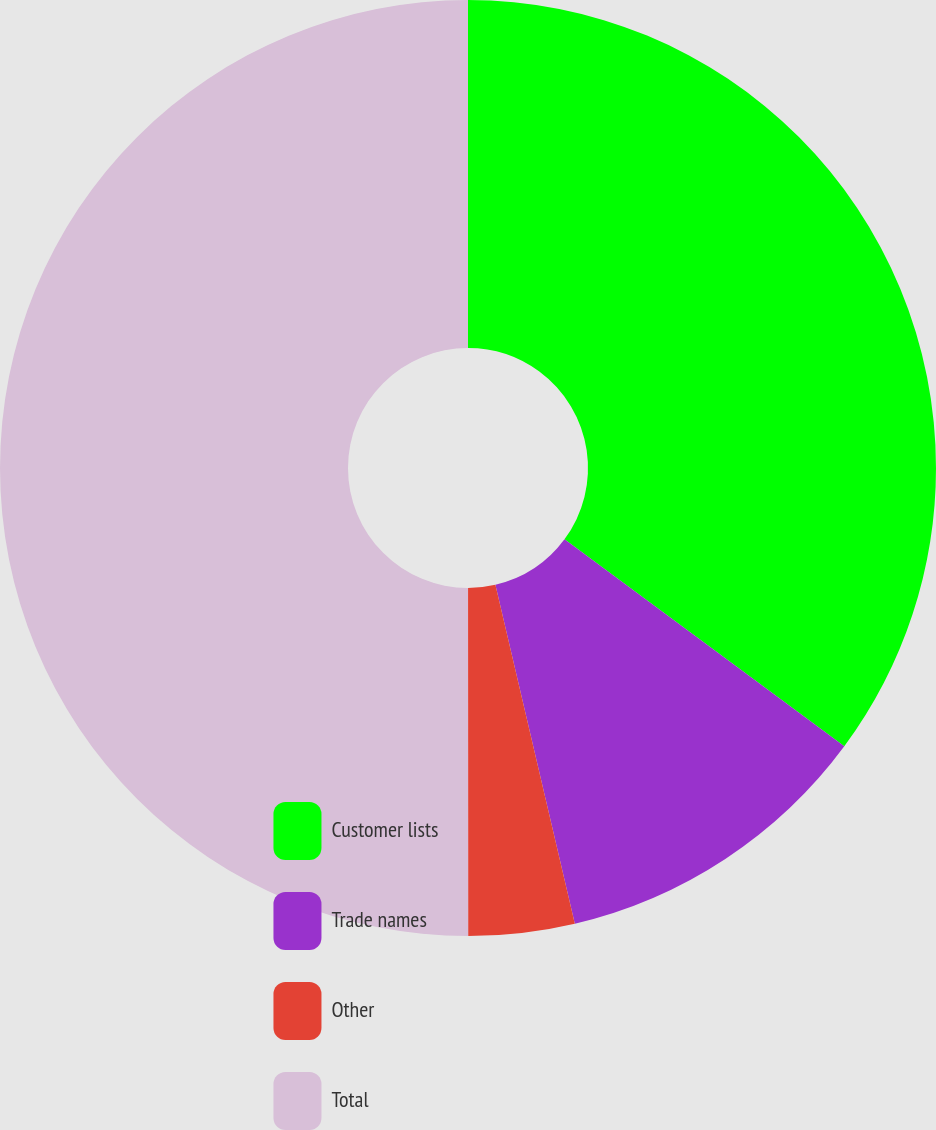Convert chart. <chart><loc_0><loc_0><loc_500><loc_500><pie_chart><fcel>Customer lists<fcel>Trade names<fcel>Other<fcel>Total<nl><fcel>35.13%<fcel>11.2%<fcel>3.66%<fcel>50.0%<nl></chart> 